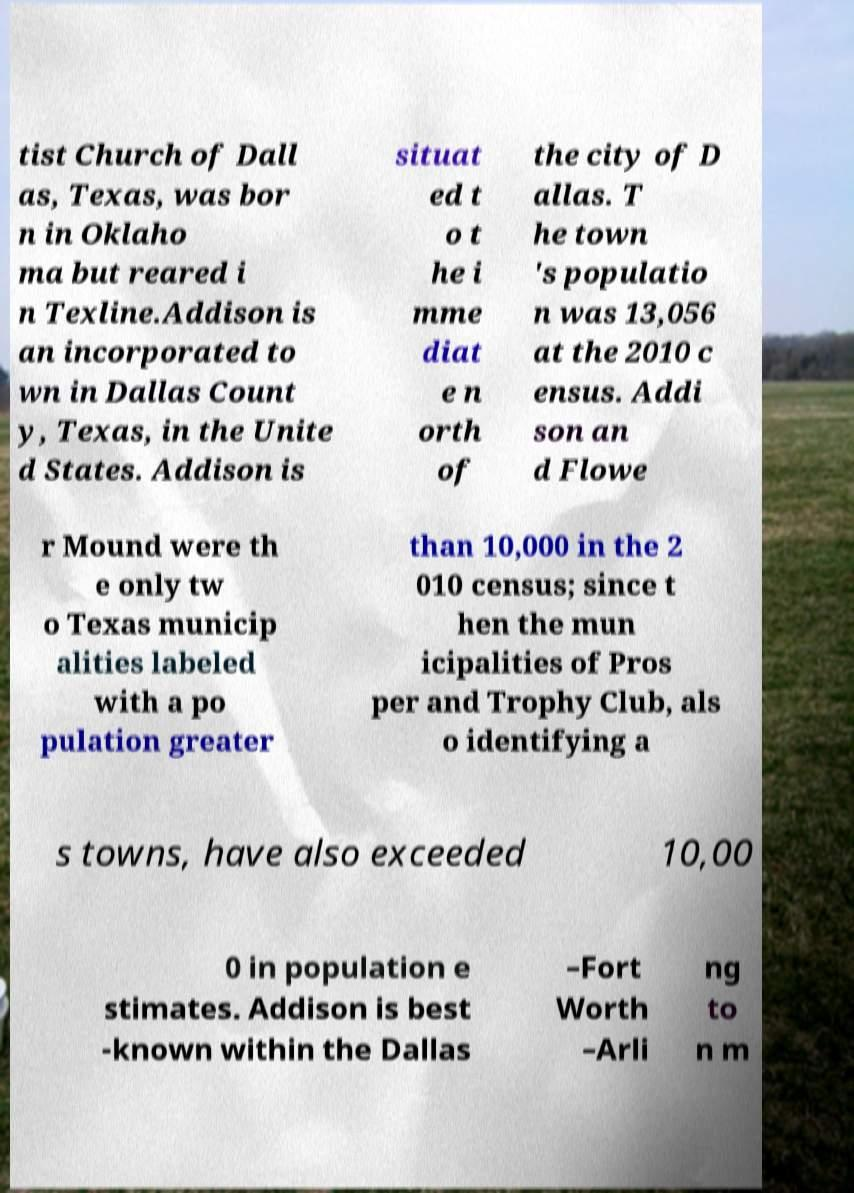Please read and relay the text visible in this image. What does it say? tist Church of Dall as, Texas, was bor n in Oklaho ma but reared i n Texline.Addison is an incorporated to wn in Dallas Count y, Texas, in the Unite d States. Addison is situat ed t o t he i mme diat e n orth of the city of D allas. T he town 's populatio n was 13,056 at the 2010 c ensus. Addi son an d Flowe r Mound were th e only tw o Texas municip alities labeled with a po pulation greater than 10,000 in the 2 010 census; since t hen the mun icipalities of Pros per and Trophy Club, als o identifying a s towns, have also exceeded 10,00 0 in population e stimates. Addison is best -known within the Dallas –Fort Worth –Arli ng to n m 